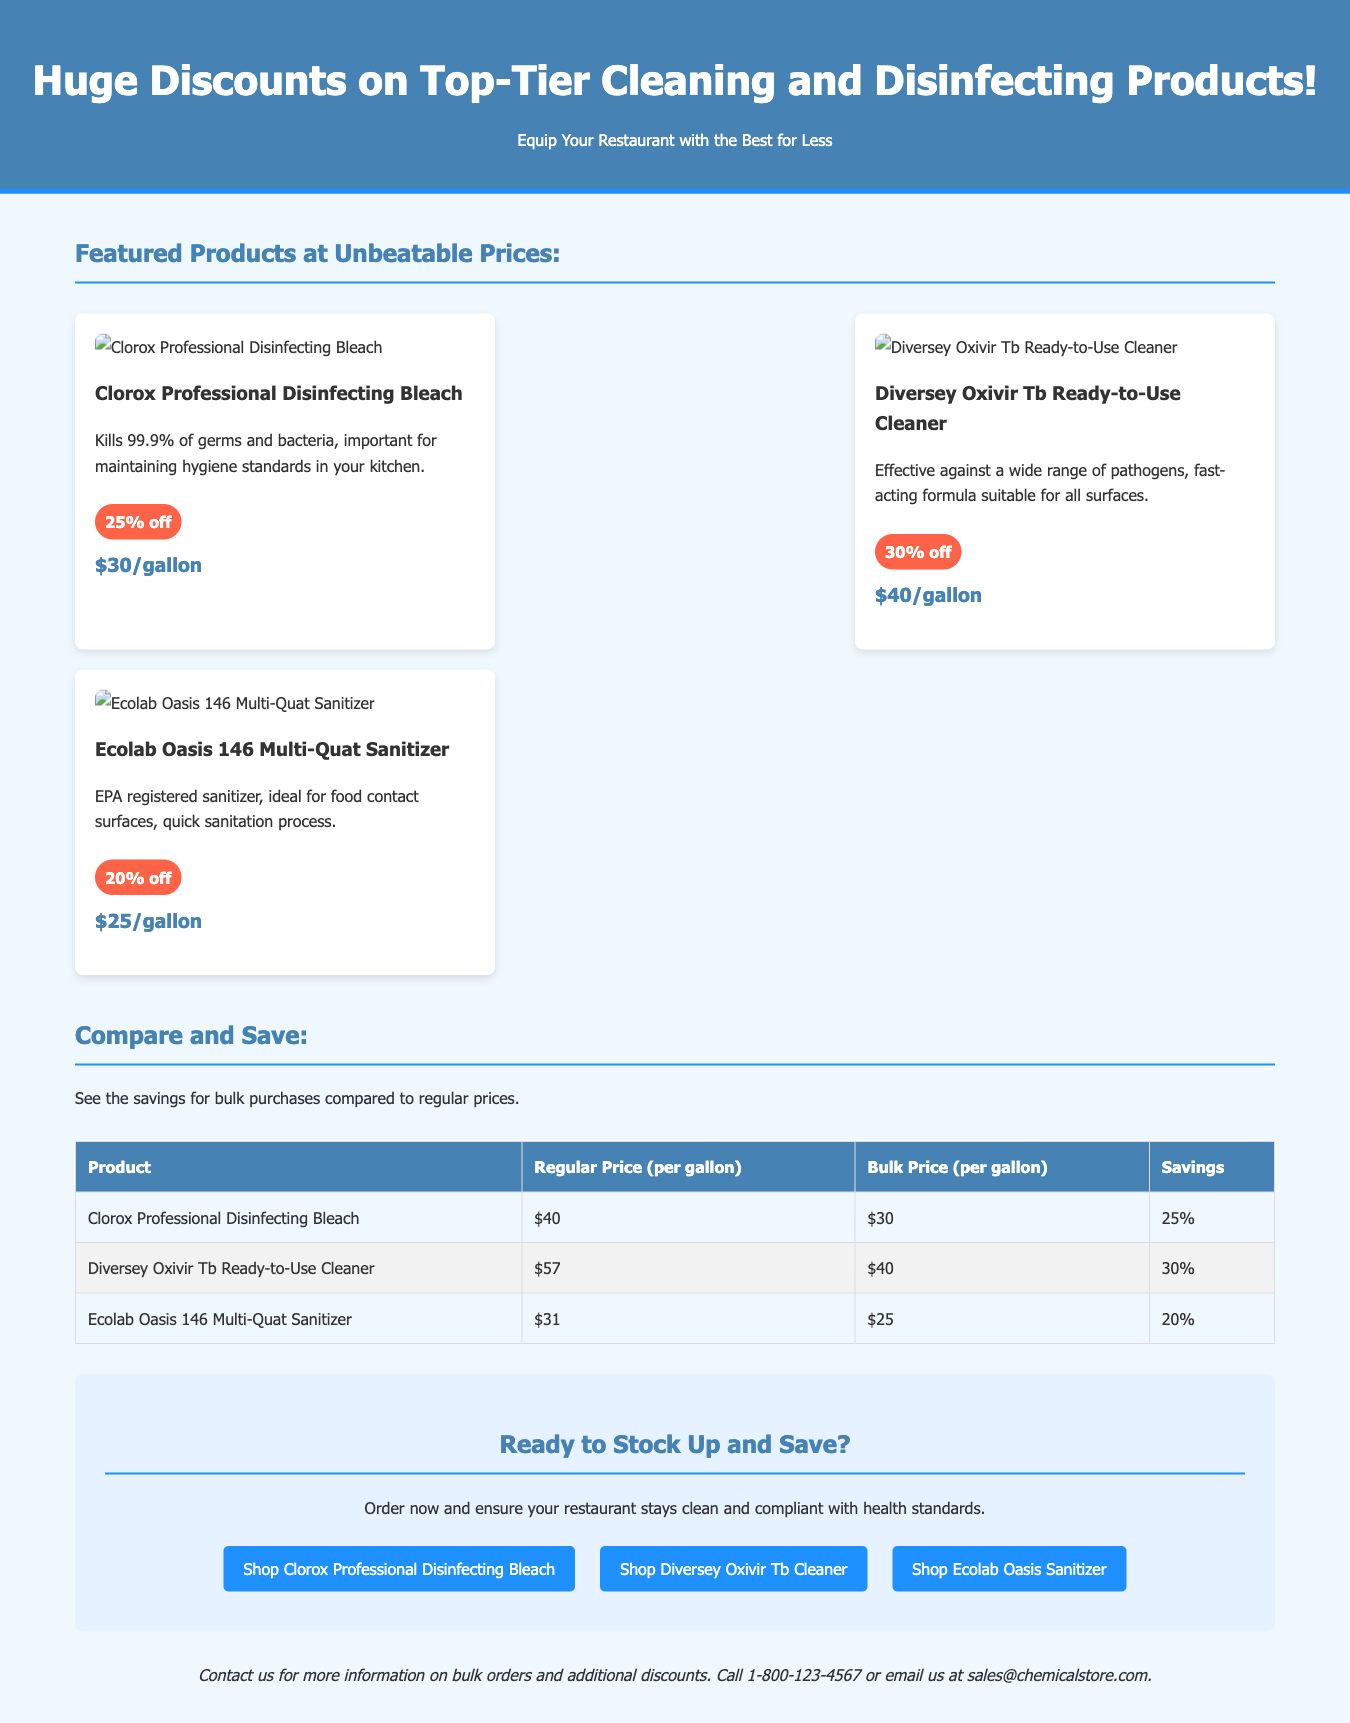What is the discount on Clorox Professional Disinfecting Bleach? The discount amount listed for Clorox Professional Disinfecting Bleach in the document is 25%.
Answer: 25% What is the bulk price for Diversey Oxivir Tb Ready-to-Use Cleaner? The bulk price for Diversey Oxivir Tb Ready-to-Use Cleaner is shown as $40 per gallon.
Answer: $40 How much can you save by purchasing Ecolab Oasis 146 Multi-Quat Sanitizer in bulk? The savings highlighted for Ecolab Oasis 146 Multi-Quat Sanitizer is 20%.
Answer: 20% What is the regular price of Clorox Professional Disinfecting Bleach per gallon? The regular price for Clorox Professional Disinfecting Bleach per gallon is $40.
Answer: $40 What call-to-action buttons are available in the advertisement? The advertisement features three call-to-action buttons for specific cleaning products.
Answer: Shop Clorox Professional Disinfecting Bleach, Shop Diversey Oxivir Tb Cleaner, Shop Ecolab Oasis Sanitizer What is the maximum discount shown for the featured products? The maximum discount emphasized for the featured cleaning products in the document is 30%.
Answer: 30% How many products are showcased in the advertisement? The advertisement showcases three different cleaning products.
Answer: Three What health standard is mentioned as a benefit of using these products? The document mentions maintaining hygiene standards in the kitchen as a benefit of using these products.
Answer: Hygiene standards What background color is used for the header section? The header section of the advertisement has a background color of #4682b4.
Answer: #4682b4 